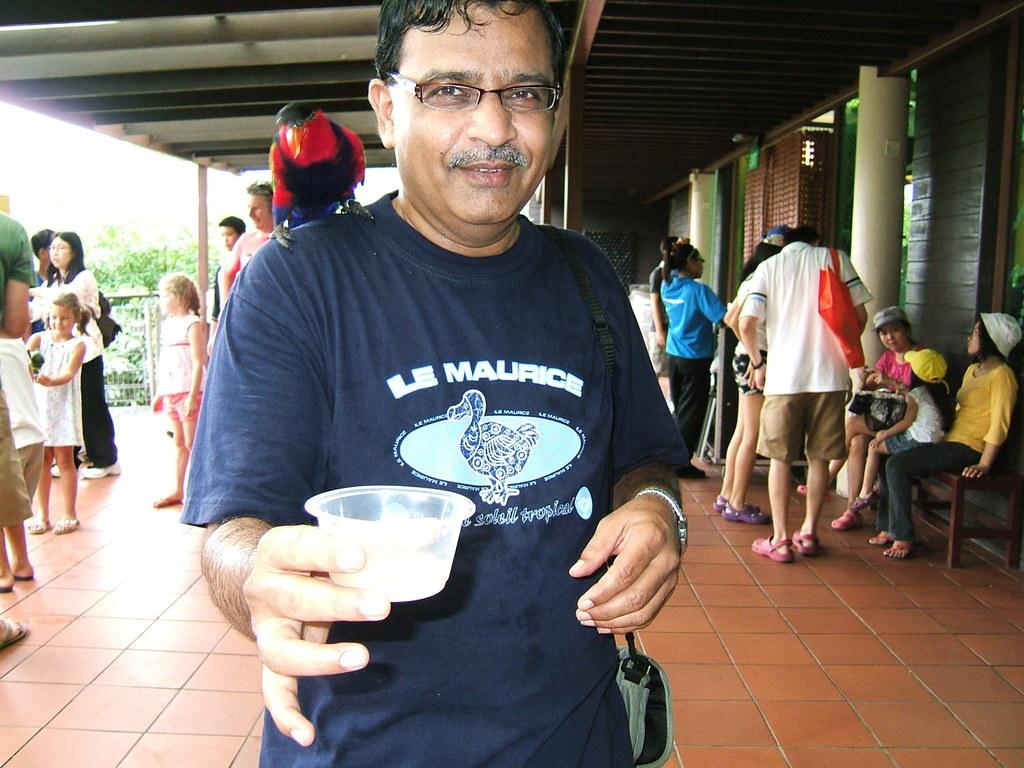How many people are in the image? There are people in the image, but the exact number is not specified. What are some of the people in the image doing? Some people are sitting on a bench. Can you describe the interaction between a person and an animal in the image? There is a bird on a person's shoulder. What is the person with the bird holding? The person with the bird is holding a cup. What type of structures can be seen in the image? There is a house in the image. What type of vegetation is present in the image? There are trees in the image. Can you hear the dog crying in the image? There is no dog or crying sound present in the image. How many stars can be seen in the image? There are no stars visible in the image. 